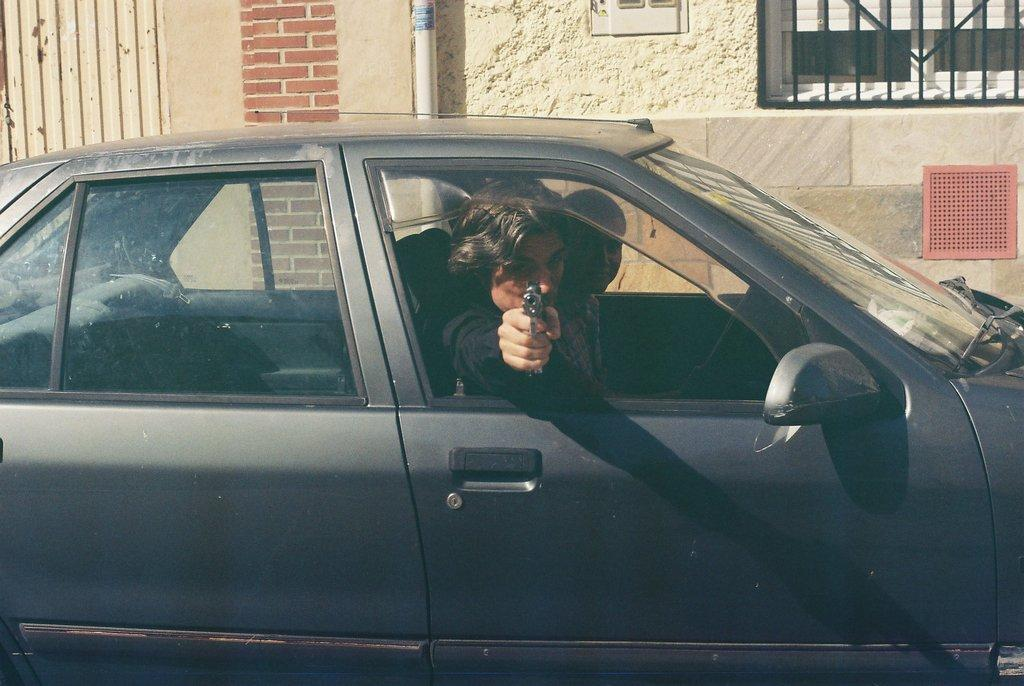How many people are in the car in the image? There are two persons sitting in the car. What can be seen in the background of the image? There is a wall, a pipe, and a railing in the background. What type of haircut does the fifth person in the image have? There is no fifth person present in the image, so it is not possible to determine their haircut. 